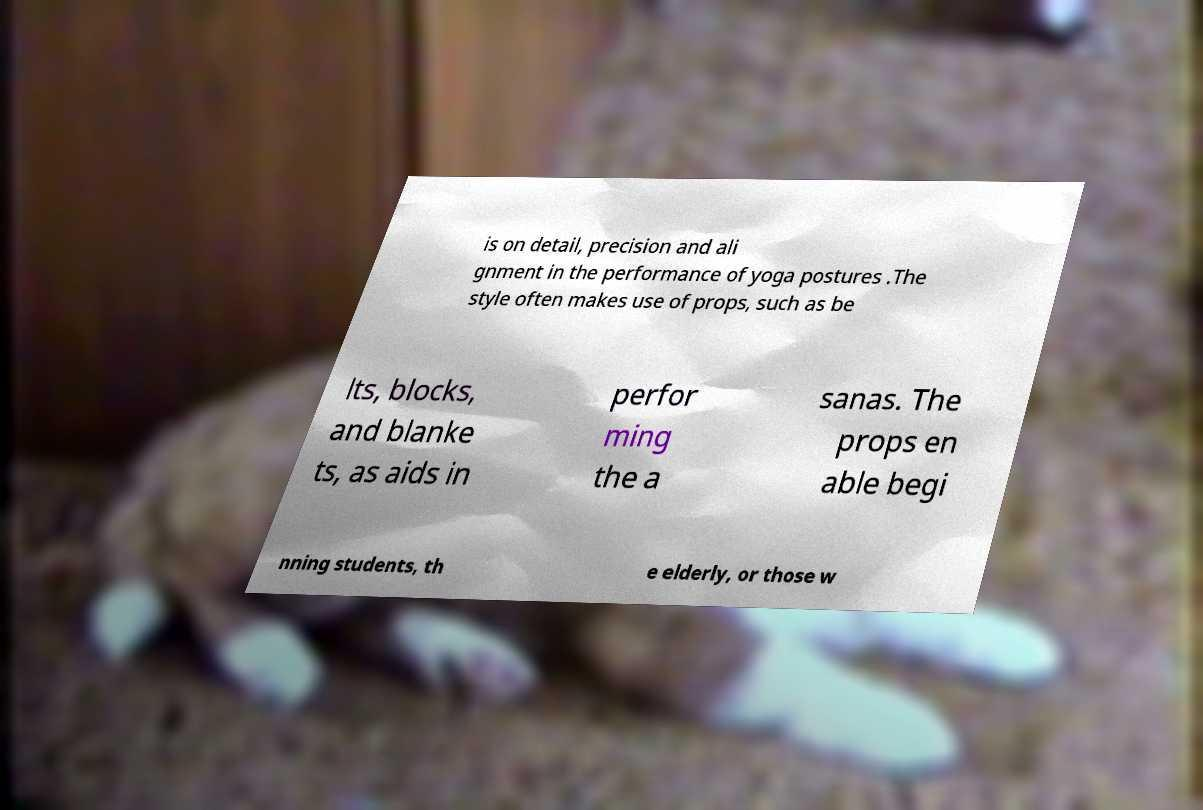I need the written content from this picture converted into text. Can you do that? is on detail, precision and ali gnment in the performance of yoga postures .The style often makes use of props, such as be lts, blocks, and blanke ts, as aids in perfor ming the a sanas. The props en able begi nning students, th e elderly, or those w 